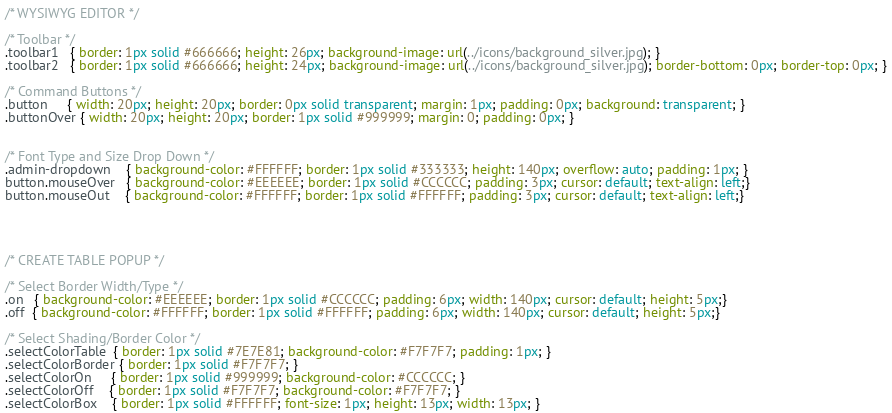<code> <loc_0><loc_0><loc_500><loc_500><_CSS_>/* WYSIWYG EDITOR */

/* Toolbar */
.toolbar1   { border: 1px solid #666666; height: 26px; background-image: url(../icons/background_silver.jpg); }
.toolbar2   { border: 1px solid #666666; height: 24px; background-image: url(../icons/background_silver.jpg); border-bottom: 0px; border-top: 0px; }

/* Command Buttons */
.button     { width: 20px; height: 20px; border: 0px solid transparent; margin: 1px; padding: 0px; background: transparent; }
.buttonOver { width: 20px; height: 20px; border: 1px solid #999999; margin: 0; padding: 0px; }


/* Font Type and Size Drop Down */
.admin-dropdown    { background-color: #FFFFFF; border: 1px solid #333333; height: 140px; overflow: auto; padding: 1px; }
button.mouseOver   { background-color: #EEEEEE; border: 1px solid #CCCCCC; padding: 3px; cursor: default; text-align: left;}
button.mouseOut    { background-color: #FFFFFF; border: 1px solid #FFFFFF; padding: 3px; cursor: default; text-align: left;}




/* CREATE TABLE POPUP */

/* Select Border Width/Type */
.on   { background-color: #EEEEEE; border: 1px solid #CCCCCC; padding: 6px; width: 140px; cursor: default; height: 5px;}
.off  { background-color: #FFFFFF; border: 1px solid #FFFFFF; padding: 6px; width: 140px; cursor: default; height: 5px;}

/* Select Shading/Border Color */
.selectColorTable  { border: 1px solid #7E7E81; background-color: #F7F7F7; padding: 1px; }
.selectColorBorder { border: 1px solid #F7F7F7; }
.selectColorOn     { border: 1px solid #999999; background-color: #CCCCCC; }
.selectColorOff    { border: 1px solid #F7F7F7; background-color: #F7F7F7; }
.selectColorBox    { border: 1px solid #FFFFFF; font-size: 1px; height: 13px; width: 13px; }</code> 